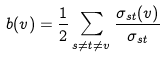<formula> <loc_0><loc_0><loc_500><loc_500>b ( v ) = \frac { 1 } { 2 } \sum _ { s \neq t \neq v } { \frac { \sigma _ { s t } ( v ) } { \sigma _ { s t } } }</formula> 